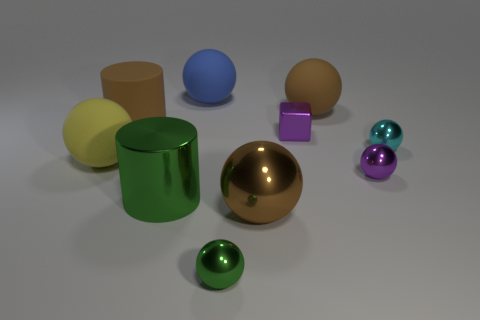How many cyan spheres are behind the large cylinder behind the yellow rubber sphere?
Your answer should be very brief. 0. What is the shape of the blue thing?
Keep it short and to the point. Sphere. What shape is the large yellow thing that is the same material as the blue sphere?
Offer a terse response. Sphere. There is a rubber thing in front of the big brown cylinder; does it have the same shape as the brown metal object?
Ensure brevity in your answer.  Yes. There is a tiny purple thing that is on the left side of the brown matte ball; what is its shape?
Offer a very short reply. Cube. What shape is the tiny object that is the same color as the metal cylinder?
Provide a short and direct response. Sphere. What number of green metallic cylinders have the same size as the cube?
Ensure brevity in your answer.  0. What color is the tiny block?
Provide a succinct answer. Purple. There is a big matte cylinder; is its color the same as the big metallic object that is left of the large blue thing?
Offer a very short reply. No. What size is the brown ball that is made of the same material as the yellow sphere?
Give a very brief answer. Large. 